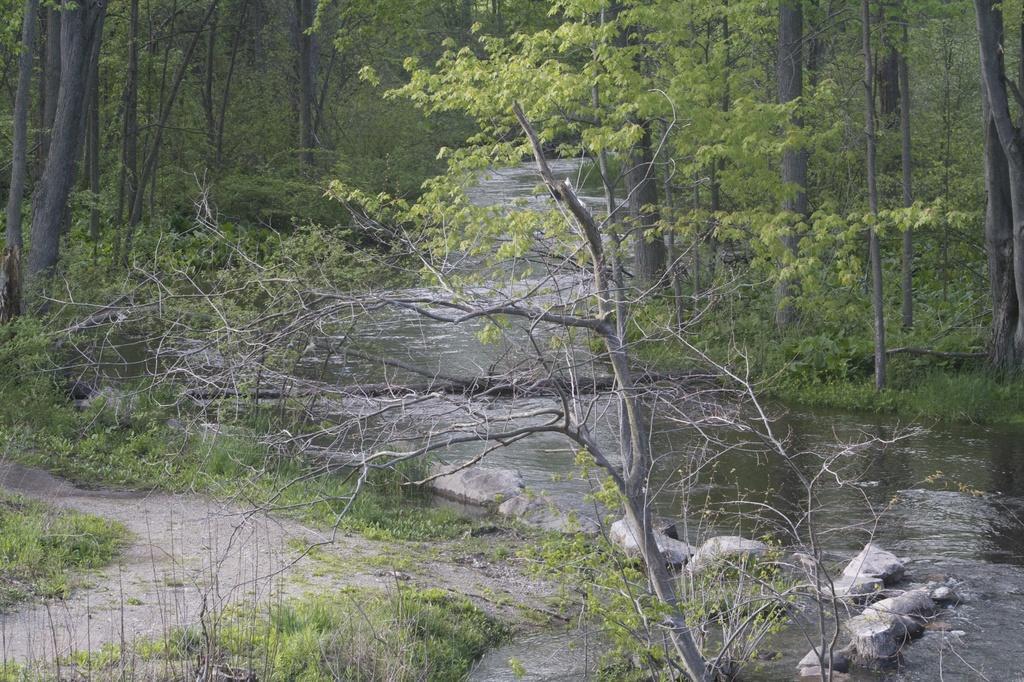How would you summarize this image in a sentence or two? In the image we can see river, stones, grass and trees. 